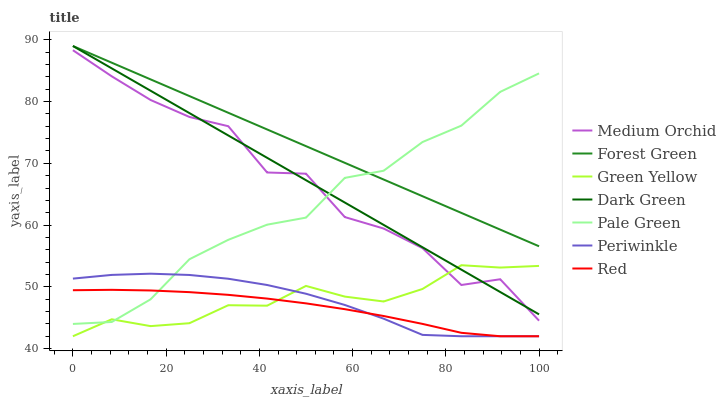Does Red have the minimum area under the curve?
Answer yes or no. Yes. Does Forest Green have the maximum area under the curve?
Answer yes or no. Yes. Does Pale Green have the minimum area under the curve?
Answer yes or no. No. Does Pale Green have the maximum area under the curve?
Answer yes or no. No. Is Forest Green the smoothest?
Answer yes or no. Yes. Is Medium Orchid the roughest?
Answer yes or no. Yes. Is Pale Green the smoothest?
Answer yes or no. No. Is Pale Green the roughest?
Answer yes or no. No. Does Periwinkle have the lowest value?
Answer yes or no. Yes. Does Pale Green have the lowest value?
Answer yes or no. No. Does Dark Green have the highest value?
Answer yes or no. Yes. Does Pale Green have the highest value?
Answer yes or no. No. Is Medium Orchid less than Forest Green?
Answer yes or no. Yes. Is Forest Green greater than Green Yellow?
Answer yes or no. Yes. Does Green Yellow intersect Red?
Answer yes or no. Yes. Is Green Yellow less than Red?
Answer yes or no. No. Is Green Yellow greater than Red?
Answer yes or no. No. Does Medium Orchid intersect Forest Green?
Answer yes or no. No. 